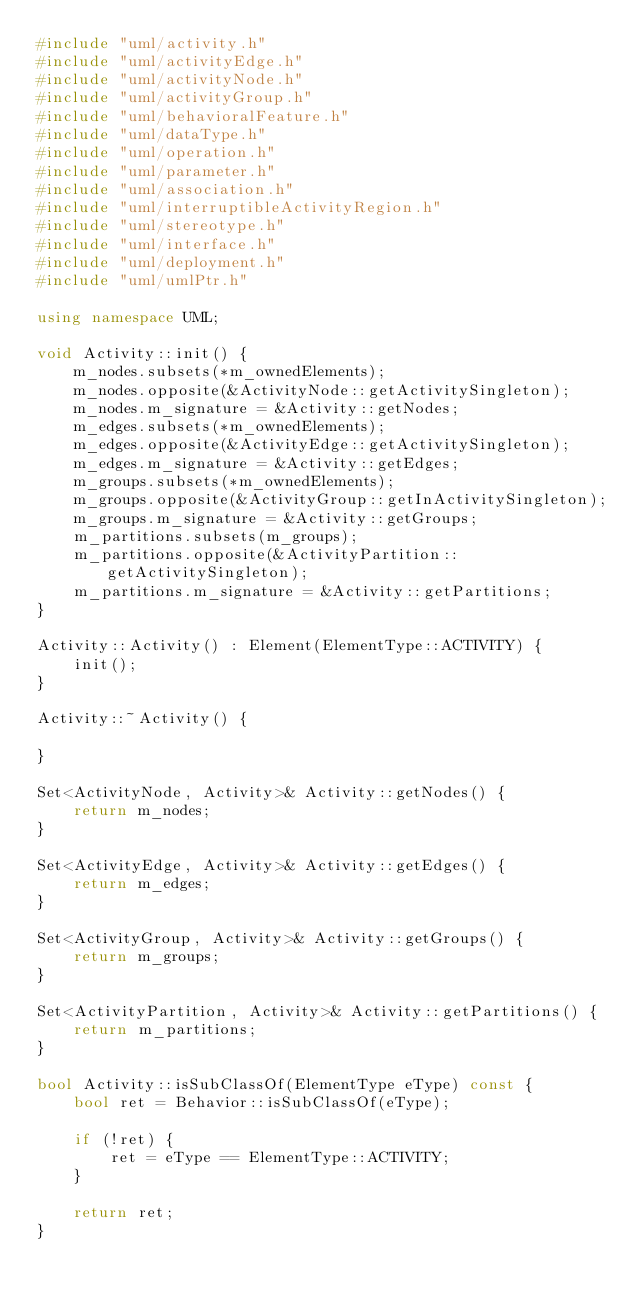Convert code to text. <code><loc_0><loc_0><loc_500><loc_500><_C++_>#include "uml/activity.h"
#include "uml/activityEdge.h"
#include "uml/activityNode.h"
#include "uml/activityGroup.h"
#include "uml/behavioralFeature.h"
#include "uml/dataType.h"
#include "uml/operation.h"
#include "uml/parameter.h"
#include "uml/association.h"
#include "uml/interruptibleActivityRegion.h"
#include "uml/stereotype.h"
#include "uml/interface.h"
#include "uml/deployment.h"
#include "uml/umlPtr.h"

using namespace UML;

void Activity::init() {
    m_nodes.subsets(*m_ownedElements);
    m_nodes.opposite(&ActivityNode::getActivitySingleton);
    m_nodes.m_signature = &Activity::getNodes;
    m_edges.subsets(*m_ownedElements);
    m_edges.opposite(&ActivityEdge::getActivitySingleton);
    m_edges.m_signature = &Activity::getEdges;
    m_groups.subsets(*m_ownedElements);
    m_groups.opposite(&ActivityGroup::getInActivitySingleton);
    m_groups.m_signature = &Activity::getGroups;
    m_partitions.subsets(m_groups);
    m_partitions.opposite(&ActivityPartition::getActivitySingleton);
    m_partitions.m_signature = &Activity::getPartitions;
}

Activity::Activity() : Element(ElementType::ACTIVITY) {
    init();
}

Activity::~Activity() {
    
}

Set<ActivityNode, Activity>& Activity::getNodes() {
    return m_nodes;
}

Set<ActivityEdge, Activity>& Activity::getEdges() {
    return m_edges;
}

Set<ActivityGroup, Activity>& Activity::getGroups() {
    return m_groups;
}

Set<ActivityPartition, Activity>& Activity::getPartitions() {
    return m_partitions;
}

bool Activity::isSubClassOf(ElementType eType) const {
    bool ret = Behavior::isSubClassOf(eType);

    if (!ret) {
        ret = eType == ElementType::ACTIVITY;
    }

    return ret;
}</code> 